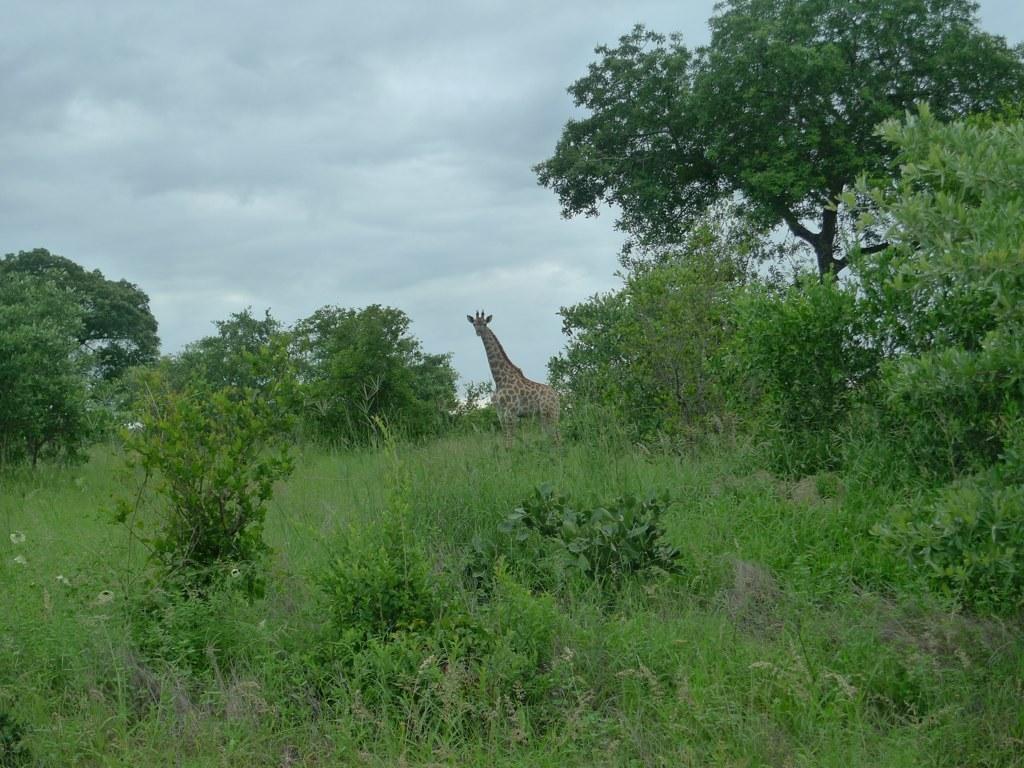Please provide a concise description of this image. In the image there are many trees, grass and plants and there is a giraffe standing on the grass in the background. 